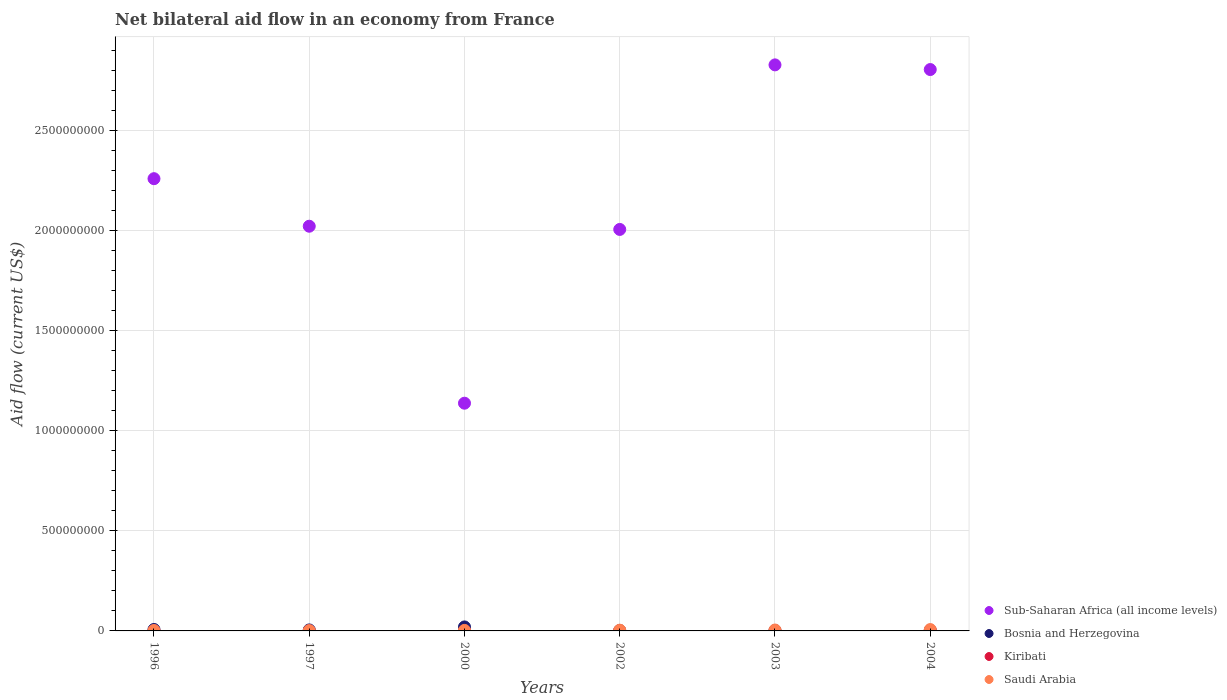How many different coloured dotlines are there?
Your response must be concise. 4. Is the number of dotlines equal to the number of legend labels?
Provide a short and direct response. Yes. What is the net bilateral aid flow in Sub-Saharan Africa (all income levels) in 2002?
Provide a succinct answer. 2.00e+09. Across all years, what is the maximum net bilateral aid flow in Saudi Arabia?
Offer a very short reply. 6.78e+06. Across all years, what is the minimum net bilateral aid flow in Kiribati?
Your answer should be compact. 10000. What is the total net bilateral aid flow in Saudi Arabia in the graph?
Your answer should be compact. 2.13e+07. What is the difference between the net bilateral aid flow in Saudi Arabia in 1996 and that in 2002?
Ensure brevity in your answer.  -1.63e+06. What is the difference between the net bilateral aid flow in Kiribati in 2003 and the net bilateral aid flow in Sub-Saharan Africa (all income levels) in 1997?
Give a very brief answer. -2.02e+09. What is the average net bilateral aid flow in Sub-Saharan Africa (all income levels) per year?
Provide a succinct answer. 2.17e+09. In the year 2004, what is the difference between the net bilateral aid flow in Bosnia and Herzegovina and net bilateral aid flow in Saudi Arabia?
Make the answer very short. -3.41e+06. In how many years, is the net bilateral aid flow in Bosnia and Herzegovina greater than 2000000000 US$?
Ensure brevity in your answer.  0. Is the difference between the net bilateral aid flow in Bosnia and Herzegovina in 2002 and 2003 greater than the difference between the net bilateral aid flow in Saudi Arabia in 2002 and 2003?
Give a very brief answer. Yes. What is the difference between the highest and the second highest net bilateral aid flow in Sub-Saharan Africa (all income levels)?
Ensure brevity in your answer.  2.33e+07. What is the difference between the highest and the lowest net bilateral aid flow in Bosnia and Herzegovina?
Provide a succinct answer. 1.78e+07. In how many years, is the net bilateral aid flow in Saudi Arabia greater than the average net bilateral aid flow in Saudi Arabia taken over all years?
Give a very brief answer. 3. Does the net bilateral aid flow in Bosnia and Herzegovina monotonically increase over the years?
Keep it short and to the point. No. How many dotlines are there?
Ensure brevity in your answer.  4. Are the values on the major ticks of Y-axis written in scientific E-notation?
Ensure brevity in your answer.  No. Does the graph contain any zero values?
Give a very brief answer. No. Does the graph contain grids?
Your answer should be very brief. Yes. Where does the legend appear in the graph?
Ensure brevity in your answer.  Bottom right. How many legend labels are there?
Your answer should be very brief. 4. How are the legend labels stacked?
Offer a terse response. Vertical. What is the title of the graph?
Give a very brief answer. Net bilateral aid flow in an economy from France. Does "Slovenia" appear as one of the legend labels in the graph?
Offer a terse response. No. What is the label or title of the X-axis?
Make the answer very short. Years. What is the Aid flow (current US$) in Sub-Saharan Africa (all income levels) in 1996?
Your answer should be very brief. 2.26e+09. What is the Aid flow (current US$) of Bosnia and Herzegovina in 1996?
Ensure brevity in your answer.  7.23e+06. What is the Aid flow (current US$) of Kiribati in 1996?
Give a very brief answer. 10000. What is the Aid flow (current US$) in Saudi Arabia in 1996?
Your answer should be very brief. 2.07e+06. What is the Aid flow (current US$) of Sub-Saharan Africa (all income levels) in 1997?
Keep it short and to the point. 2.02e+09. What is the Aid flow (current US$) of Bosnia and Herzegovina in 1997?
Provide a succinct answer. 4.96e+06. What is the Aid flow (current US$) of Kiribati in 1997?
Give a very brief answer. 10000. What is the Aid flow (current US$) in Saudi Arabia in 1997?
Your answer should be compact. 1.61e+06. What is the Aid flow (current US$) of Sub-Saharan Africa (all income levels) in 2000?
Provide a succinct answer. 1.14e+09. What is the Aid flow (current US$) of Bosnia and Herzegovina in 2000?
Provide a short and direct response. 1.99e+07. What is the Aid flow (current US$) in Saudi Arabia in 2000?
Offer a very short reply. 2.57e+06. What is the Aid flow (current US$) of Sub-Saharan Africa (all income levels) in 2002?
Give a very brief answer. 2.00e+09. What is the Aid flow (current US$) in Bosnia and Herzegovina in 2002?
Make the answer very short. 2.39e+06. What is the Aid flow (current US$) of Saudi Arabia in 2002?
Your answer should be very brief. 3.70e+06. What is the Aid flow (current US$) in Sub-Saharan Africa (all income levels) in 2003?
Ensure brevity in your answer.  2.83e+09. What is the Aid flow (current US$) in Bosnia and Herzegovina in 2003?
Your answer should be compact. 2.07e+06. What is the Aid flow (current US$) of Saudi Arabia in 2003?
Offer a very short reply. 4.55e+06. What is the Aid flow (current US$) in Sub-Saharan Africa (all income levels) in 2004?
Give a very brief answer. 2.80e+09. What is the Aid flow (current US$) of Bosnia and Herzegovina in 2004?
Make the answer very short. 3.37e+06. What is the Aid flow (current US$) of Saudi Arabia in 2004?
Offer a terse response. 6.78e+06. Across all years, what is the maximum Aid flow (current US$) in Sub-Saharan Africa (all income levels)?
Provide a succinct answer. 2.83e+09. Across all years, what is the maximum Aid flow (current US$) of Bosnia and Herzegovina?
Give a very brief answer. 1.99e+07. Across all years, what is the maximum Aid flow (current US$) of Saudi Arabia?
Keep it short and to the point. 6.78e+06. Across all years, what is the minimum Aid flow (current US$) in Sub-Saharan Africa (all income levels)?
Provide a short and direct response. 1.14e+09. Across all years, what is the minimum Aid flow (current US$) of Bosnia and Herzegovina?
Your answer should be compact. 2.07e+06. Across all years, what is the minimum Aid flow (current US$) in Kiribati?
Give a very brief answer. 10000. Across all years, what is the minimum Aid flow (current US$) of Saudi Arabia?
Make the answer very short. 1.61e+06. What is the total Aid flow (current US$) in Sub-Saharan Africa (all income levels) in the graph?
Provide a short and direct response. 1.30e+1. What is the total Aid flow (current US$) of Bosnia and Herzegovina in the graph?
Keep it short and to the point. 3.99e+07. What is the total Aid flow (current US$) in Saudi Arabia in the graph?
Offer a very short reply. 2.13e+07. What is the difference between the Aid flow (current US$) in Sub-Saharan Africa (all income levels) in 1996 and that in 1997?
Your answer should be compact. 2.37e+08. What is the difference between the Aid flow (current US$) of Bosnia and Herzegovina in 1996 and that in 1997?
Your response must be concise. 2.27e+06. What is the difference between the Aid flow (current US$) of Kiribati in 1996 and that in 1997?
Provide a succinct answer. 0. What is the difference between the Aid flow (current US$) of Sub-Saharan Africa (all income levels) in 1996 and that in 2000?
Your answer should be compact. 1.12e+09. What is the difference between the Aid flow (current US$) in Bosnia and Herzegovina in 1996 and that in 2000?
Your answer should be compact. -1.27e+07. What is the difference between the Aid flow (current US$) in Saudi Arabia in 1996 and that in 2000?
Provide a succinct answer. -5.00e+05. What is the difference between the Aid flow (current US$) in Sub-Saharan Africa (all income levels) in 1996 and that in 2002?
Your answer should be very brief. 2.53e+08. What is the difference between the Aid flow (current US$) of Bosnia and Herzegovina in 1996 and that in 2002?
Ensure brevity in your answer.  4.84e+06. What is the difference between the Aid flow (current US$) in Kiribati in 1996 and that in 2002?
Your answer should be compact. -5.00e+04. What is the difference between the Aid flow (current US$) in Saudi Arabia in 1996 and that in 2002?
Ensure brevity in your answer.  -1.63e+06. What is the difference between the Aid flow (current US$) in Sub-Saharan Africa (all income levels) in 1996 and that in 2003?
Ensure brevity in your answer.  -5.68e+08. What is the difference between the Aid flow (current US$) of Bosnia and Herzegovina in 1996 and that in 2003?
Ensure brevity in your answer.  5.16e+06. What is the difference between the Aid flow (current US$) of Kiribati in 1996 and that in 2003?
Ensure brevity in your answer.  -3.00e+04. What is the difference between the Aid flow (current US$) of Saudi Arabia in 1996 and that in 2003?
Your answer should be compact. -2.48e+06. What is the difference between the Aid flow (current US$) in Sub-Saharan Africa (all income levels) in 1996 and that in 2004?
Your response must be concise. -5.45e+08. What is the difference between the Aid flow (current US$) in Bosnia and Herzegovina in 1996 and that in 2004?
Provide a succinct answer. 3.86e+06. What is the difference between the Aid flow (current US$) in Kiribati in 1996 and that in 2004?
Your response must be concise. -3.00e+04. What is the difference between the Aid flow (current US$) of Saudi Arabia in 1996 and that in 2004?
Keep it short and to the point. -4.71e+06. What is the difference between the Aid flow (current US$) of Sub-Saharan Africa (all income levels) in 1997 and that in 2000?
Your answer should be very brief. 8.84e+08. What is the difference between the Aid flow (current US$) of Bosnia and Herzegovina in 1997 and that in 2000?
Make the answer very short. -1.50e+07. What is the difference between the Aid flow (current US$) in Kiribati in 1997 and that in 2000?
Offer a terse response. -10000. What is the difference between the Aid flow (current US$) in Saudi Arabia in 1997 and that in 2000?
Give a very brief answer. -9.60e+05. What is the difference between the Aid flow (current US$) in Sub-Saharan Africa (all income levels) in 1997 and that in 2002?
Offer a very short reply. 1.60e+07. What is the difference between the Aid flow (current US$) of Bosnia and Herzegovina in 1997 and that in 2002?
Your response must be concise. 2.57e+06. What is the difference between the Aid flow (current US$) of Saudi Arabia in 1997 and that in 2002?
Make the answer very short. -2.09e+06. What is the difference between the Aid flow (current US$) of Sub-Saharan Africa (all income levels) in 1997 and that in 2003?
Provide a short and direct response. -8.06e+08. What is the difference between the Aid flow (current US$) in Bosnia and Herzegovina in 1997 and that in 2003?
Provide a succinct answer. 2.89e+06. What is the difference between the Aid flow (current US$) in Saudi Arabia in 1997 and that in 2003?
Make the answer very short. -2.94e+06. What is the difference between the Aid flow (current US$) of Sub-Saharan Africa (all income levels) in 1997 and that in 2004?
Provide a short and direct response. -7.82e+08. What is the difference between the Aid flow (current US$) in Bosnia and Herzegovina in 1997 and that in 2004?
Your response must be concise. 1.59e+06. What is the difference between the Aid flow (current US$) of Kiribati in 1997 and that in 2004?
Make the answer very short. -3.00e+04. What is the difference between the Aid flow (current US$) in Saudi Arabia in 1997 and that in 2004?
Offer a very short reply. -5.17e+06. What is the difference between the Aid flow (current US$) of Sub-Saharan Africa (all income levels) in 2000 and that in 2002?
Provide a succinct answer. -8.68e+08. What is the difference between the Aid flow (current US$) in Bosnia and Herzegovina in 2000 and that in 2002?
Give a very brief answer. 1.75e+07. What is the difference between the Aid flow (current US$) of Saudi Arabia in 2000 and that in 2002?
Your response must be concise. -1.13e+06. What is the difference between the Aid flow (current US$) of Sub-Saharan Africa (all income levels) in 2000 and that in 2003?
Offer a terse response. -1.69e+09. What is the difference between the Aid flow (current US$) of Bosnia and Herzegovina in 2000 and that in 2003?
Provide a succinct answer. 1.78e+07. What is the difference between the Aid flow (current US$) in Saudi Arabia in 2000 and that in 2003?
Make the answer very short. -1.98e+06. What is the difference between the Aid flow (current US$) of Sub-Saharan Africa (all income levels) in 2000 and that in 2004?
Provide a short and direct response. -1.67e+09. What is the difference between the Aid flow (current US$) of Bosnia and Herzegovina in 2000 and that in 2004?
Your response must be concise. 1.65e+07. What is the difference between the Aid flow (current US$) of Saudi Arabia in 2000 and that in 2004?
Give a very brief answer. -4.21e+06. What is the difference between the Aid flow (current US$) in Sub-Saharan Africa (all income levels) in 2002 and that in 2003?
Your response must be concise. -8.22e+08. What is the difference between the Aid flow (current US$) in Bosnia and Herzegovina in 2002 and that in 2003?
Your answer should be compact. 3.20e+05. What is the difference between the Aid flow (current US$) in Kiribati in 2002 and that in 2003?
Make the answer very short. 2.00e+04. What is the difference between the Aid flow (current US$) in Saudi Arabia in 2002 and that in 2003?
Your response must be concise. -8.50e+05. What is the difference between the Aid flow (current US$) in Sub-Saharan Africa (all income levels) in 2002 and that in 2004?
Keep it short and to the point. -7.98e+08. What is the difference between the Aid flow (current US$) of Bosnia and Herzegovina in 2002 and that in 2004?
Offer a very short reply. -9.80e+05. What is the difference between the Aid flow (current US$) in Saudi Arabia in 2002 and that in 2004?
Provide a succinct answer. -3.08e+06. What is the difference between the Aid flow (current US$) in Sub-Saharan Africa (all income levels) in 2003 and that in 2004?
Provide a succinct answer. 2.33e+07. What is the difference between the Aid flow (current US$) in Bosnia and Herzegovina in 2003 and that in 2004?
Provide a short and direct response. -1.30e+06. What is the difference between the Aid flow (current US$) in Kiribati in 2003 and that in 2004?
Your response must be concise. 0. What is the difference between the Aid flow (current US$) of Saudi Arabia in 2003 and that in 2004?
Keep it short and to the point. -2.23e+06. What is the difference between the Aid flow (current US$) in Sub-Saharan Africa (all income levels) in 1996 and the Aid flow (current US$) in Bosnia and Herzegovina in 1997?
Offer a terse response. 2.25e+09. What is the difference between the Aid flow (current US$) in Sub-Saharan Africa (all income levels) in 1996 and the Aid flow (current US$) in Kiribati in 1997?
Provide a succinct answer. 2.26e+09. What is the difference between the Aid flow (current US$) in Sub-Saharan Africa (all income levels) in 1996 and the Aid flow (current US$) in Saudi Arabia in 1997?
Your answer should be compact. 2.26e+09. What is the difference between the Aid flow (current US$) of Bosnia and Herzegovina in 1996 and the Aid flow (current US$) of Kiribati in 1997?
Provide a short and direct response. 7.22e+06. What is the difference between the Aid flow (current US$) of Bosnia and Herzegovina in 1996 and the Aid flow (current US$) of Saudi Arabia in 1997?
Offer a very short reply. 5.62e+06. What is the difference between the Aid flow (current US$) in Kiribati in 1996 and the Aid flow (current US$) in Saudi Arabia in 1997?
Give a very brief answer. -1.60e+06. What is the difference between the Aid flow (current US$) in Sub-Saharan Africa (all income levels) in 1996 and the Aid flow (current US$) in Bosnia and Herzegovina in 2000?
Keep it short and to the point. 2.24e+09. What is the difference between the Aid flow (current US$) in Sub-Saharan Africa (all income levels) in 1996 and the Aid flow (current US$) in Kiribati in 2000?
Keep it short and to the point. 2.26e+09. What is the difference between the Aid flow (current US$) of Sub-Saharan Africa (all income levels) in 1996 and the Aid flow (current US$) of Saudi Arabia in 2000?
Provide a succinct answer. 2.26e+09. What is the difference between the Aid flow (current US$) of Bosnia and Herzegovina in 1996 and the Aid flow (current US$) of Kiribati in 2000?
Keep it short and to the point. 7.21e+06. What is the difference between the Aid flow (current US$) of Bosnia and Herzegovina in 1996 and the Aid flow (current US$) of Saudi Arabia in 2000?
Keep it short and to the point. 4.66e+06. What is the difference between the Aid flow (current US$) of Kiribati in 1996 and the Aid flow (current US$) of Saudi Arabia in 2000?
Offer a very short reply. -2.56e+06. What is the difference between the Aid flow (current US$) of Sub-Saharan Africa (all income levels) in 1996 and the Aid flow (current US$) of Bosnia and Herzegovina in 2002?
Provide a succinct answer. 2.26e+09. What is the difference between the Aid flow (current US$) in Sub-Saharan Africa (all income levels) in 1996 and the Aid flow (current US$) in Kiribati in 2002?
Your response must be concise. 2.26e+09. What is the difference between the Aid flow (current US$) in Sub-Saharan Africa (all income levels) in 1996 and the Aid flow (current US$) in Saudi Arabia in 2002?
Your response must be concise. 2.25e+09. What is the difference between the Aid flow (current US$) in Bosnia and Herzegovina in 1996 and the Aid flow (current US$) in Kiribati in 2002?
Keep it short and to the point. 7.17e+06. What is the difference between the Aid flow (current US$) in Bosnia and Herzegovina in 1996 and the Aid flow (current US$) in Saudi Arabia in 2002?
Make the answer very short. 3.53e+06. What is the difference between the Aid flow (current US$) of Kiribati in 1996 and the Aid flow (current US$) of Saudi Arabia in 2002?
Your response must be concise. -3.69e+06. What is the difference between the Aid flow (current US$) of Sub-Saharan Africa (all income levels) in 1996 and the Aid flow (current US$) of Bosnia and Herzegovina in 2003?
Provide a succinct answer. 2.26e+09. What is the difference between the Aid flow (current US$) in Sub-Saharan Africa (all income levels) in 1996 and the Aid flow (current US$) in Kiribati in 2003?
Ensure brevity in your answer.  2.26e+09. What is the difference between the Aid flow (current US$) in Sub-Saharan Africa (all income levels) in 1996 and the Aid flow (current US$) in Saudi Arabia in 2003?
Give a very brief answer. 2.25e+09. What is the difference between the Aid flow (current US$) in Bosnia and Herzegovina in 1996 and the Aid flow (current US$) in Kiribati in 2003?
Provide a succinct answer. 7.19e+06. What is the difference between the Aid flow (current US$) in Bosnia and Herzegovina in 1996 and the Aid flow (current US$) in Saudi Arabia in 2003?
Your response must be concise. 2.68e+06. What is the difference between the Aid flow (current US$) in Kiribati in 1996 and the Aid flow (current US$) in Saudi Arabia in 2003?
Give a very brief answer. -4.54e+06. What is the difference between the Aid flow (current US$) of Sub-Saharan Africa (all income levels) in 1996 and the Aid flow (current US$) of Bosnia and Herzegovina in 2004?
Your answer should be very brief. 2.25e+09. What is the difference between the Aid flow (current US$) in Sub-Saharan Africa (all income levels) in 1996 and the Aid flow (current US$) in Kiribati in 2004?
Your answer should be very brief. 2.26e+09. What is the difference between the Aid flow (current US$) in Sub-Saharan Africa (all income levels) in 1996 and the Aid flow (current US$) in Saudi Arabia in 2004?
Ensure brevity in your answer.  2.25e+09. What is the difference between the Aid flow (current US$) of Bosnia and Herzegovina in 1996 and the Aid flow (current US$) of Kiribati in 2004?
Offer a terse response. 7.19e+06. What is the difference between the Aid flow (current US$) of Kiribati in 1996 and the Aid flow (current US$) of Saudi Arabia in 2004?
Offer a very short reply. -6.77e+06. What is the difference between the Aid flow (current US$) of Sub-Saharan Africa (all income levels) in 1997 and the Aid flow (current US$) of Bosnia and Herzegovina in 2000?
Your response must be concise. 2.00e+09. What is the difference between the Aid flow (current US$) of Sub-Saharan Africa (all income levels) in 1997 and the Aid flow (current US$) of Kiribati in 2000?
Provide a succinct answer. 2.02e+09. What is the difference between the Aid flow (current US$) of Sub-Saharan Africa (all income levels) in 1997 and the Aid flow (current US$) of Saudi Arabia in 2000?
Your answer should be compact. 2.02e+09. What is the difference between the Aid flow (current US$) in Bosnia and Herzegovina in 1997 and the Aid flow (current US$) in Kiribati in 2000?
Your response must be concise. 4.94e+06. What is the difference between the Aid flow (current US$) of Bosnia and Herzegovina in 1997 and the Aid flow (current US$) of Saudi Arabia in 2000?
Provide a succinct answer. 2.39e+06. What is the difference between the Aid flow (current US$) of Kiribati in 1997 and the Aid flow (current US$) of Saudi Arabia in 2000?
Make the answer very short. -2.56e+06. What is the difference between the Aid flow (current US$) of Sub-Saharan Africa (all income levels) in 1997 and the Aid flow (current US$) of Bosnia and Herzegovina in 2002?
Give a very brief answer. 2.02e+09. What is the difference between the Aid flow (current US$) in Sub-Saharan Africa (all income levels) in 1997 and the Aid flow (current US$) in Kiribati in 2002?
Keep it short and to the point. 2.02e+09. What is the difference between the Aid flow (current US$) of Sub-Saharan Africa (all income levels) in 1997 and the Aid flow (current US$) of Saudi Arabia in 2002?
Your answer should be compact. 2.02e+09. What is the difference between the Aid flow (current US$) in Bosnia and Herzegovina in 1997 and the Aid flow (current US$) in Kiribati in 2002?
Keep it short and to the point. 4.90e+06. What is the difference between the Aid flow (current US$) in Bosnia and Herzegovina in 1997 and the Aid flow (current US$) in Saudi Arabia in 2002?
Your answer should be very brief. 1.26e+06. What is the difference between the Aid flow (current US$) in Kiribati in 1997 and the Aid flow (current US$) in Saudi Arabia in 2002?
Your response must be concise. -3.69e+06. What is the difference between the Aid flow (current US$) of Sub-Saharan Africa (all income levels) in 1997 and the Aid flow (current US$) of Bosnia and Herzegovina in 2003?
Keep it short and to the point. 2.02e+09. What is the difference between the Aid flow (current US$) of Sub-Saharan Africa (all income levels) in 1997 and the Aid flow (current US$) of Kiribati in 2003?
Make the answer very short. 2.02e+09. What is the difference between the Aid flow (current US$) in Sub-Saharan Africa (all income levels) in 1997 and the Aid flow (current US$) in Saudi Arabia in 2003?
Ensure brevity in your answer.  2.02e+09. What is the difference between the Aid flow (current US$) in Bosnia and Herzegovina in 1997 and the Aid flow (current US$) in Kiribati in 2003?
Your answer should be compact. 4.92e+06. What is the difference between the Aid flow (current US$) in Kiribati in 1997 and the Aid flow (current US$) in Saudi Arabia in 2003?
Ensure brevity in your answer.  -4.54e+06. What is the difference between the Aid flow (current US$) of Sub-Saharan Africa (all income levels) in 1997 and the Aid flow (current US$) of Bosnia and Herzegovina in 2004?
Make the answer very short. 2.02e+09. What is the difference between the Aid flow (current US$) in Sub-Saharan Africa (all income levels) in 1997 and the Aid flow (current US$) in Kiribati in 2004?
Make the answer very short. 2.02e+09. What is the difference between the Aid flow (current US$) in Sub-Saharan Africa (all income levels) in 1997 and the Aid flow (current US$) in Saudi Arabia in 2004?
Keep it short and to the point. 2.01e+09. What is the difference between the Aid flow (current US$) in Bosnia and Herzegovina in 1997 and the Aid flow (current US$) in Kiribati in 2004?
Your response must be concise. 4.92e+06. What is the difference between the Aid flow (current US$) of Bosnia and Herzegovina in 1997 and the Aid flow (current US$) of Saudi Arabia in 2004?
Your answer should be very brief. -1.82e+06. What is the difference between the Aid flow (current US$) in Kiribati in 1997 and the Aid flow (current US$) in Saudi Arabia in 2004?
Your answer should be compact. -6.77e+06. What is the difference between the Aid flow (current US$) in Sub-Saharan Africa (all income levels) in 2000 and the Aid flow (current US$) in Bosnia and Herzegovina in 2002?
Your response must be concise. 1.13e+09. What is the difference between the Aid flow (current US$) of Sub-Saharan Africa (all income levels) in 2000 and the Aid flow (current US$) of Kiribati in 2002?
Your response must be concise. 1.14e+09. What is the difference between the Aid flow (current US$) in Sub-Saharan Africa (all income levels) in 2000 and the Aid flow (current US$) in Saudi Arabia in 2002?
Offer a terse response. 1.13e+09. What is the difference between the Aid flow (current US$) in Bosnia and Herzegovina in 2000 and the Aid flow (current US$) in Kiribati in 2002?
Your answer should be compact. 1.98e+07. What is the difference between the Aid flow (current US$) in Bosnia and Herzegovina in 2000 and the Aid flow (current US$) in Saudi Arabia in 2002?
Provide a succinct answer. 1.62e+07. What is the difference between the Aid flow (current US$) in Kiribati in 2000 and the Aid flow (current US$) in Saudi Arabia in 2002?
Give a very brief answer. -3.68e+06. What is the difference between the Aid flow (current US$) in Sub-Saharan Africa (all income levels) in 2000 and the Aid flow (current US$) in Bosnia and Herzegovina in 2003?
Your answer should be compact. 1.13e+09. What is the difference between the Aid flow (current US$) of Sub-Saharan Africa (all income levels) in 2000 and the Aid flow (current US$) of Kiribati in 2003?
Offer a very short reply. 1.14e+09. What is the difference between the Aid flow (current US$) in Sub-Saharan Africa (all income levels) in 2000 and the Aid flow (current US$) in Saudi Arabia in 2003?
Make the answer very short. 1.13e+09. What is the difference between the Aid flow (current US$) in Bosnia and Herzegovina in 2000 and the Aid flow (current US$) in Kiribati in 2003?
Make the answer very short. 1.99e+07. What is the difference between the Aid flow (current US$) in Bosnia and Herzegovina in 2000 and the Aid flow (current US$) in Saudi Arabia in 2003?
Your response must be concise. 1.54e+07. What is the difference between the Aid flow (current US$) in Kiribati in 2000 and the Aid flow (current US$) in Saudi Arabia in 2003?
Your response must be concise. -4.53e+06. What is the difference between the Aid flow (current US$) in Sub-Saharan Africa (all income levels) in 2000 and the Aid flow (current US$) in Bosnia and Herzegovina in 2004?
Your answer should be very brief. 1.13e+09. What is the difference between the Aid flow (current US$) of Sub-Saharan Africa (all income levels) in 2000 and the Aid flow (current US$) of Kiribati in 2004?
Give a very brief answer. 1.14e+09. What is the difference between the Aid flow (current US$) in Sub-Saharan Africa (all income levels) in 2000 and the Aid flow (current US$) in Saudi Arabia in 2004?
Keep it short and to the point. 1.13e+09. What is the difference between the Aid flow (current US$) of Bosnia and Herzegovina in 2000 and the Aid flow (current US$) of Kiribati in 2004?
Your answer should be very brief. 1.99e+07. What is the difference between the Aid flow (current US$) in Bosnia and Herzegovina in 2000 and the Aid flow (current US$) in Saudi Arabia in 2004?
Your answer should be compact. 1.31e+07. What is the difference between the Aid flow (current US$) in Kiribati in 2000 and the Aid flow (current US$) in Saudi Arabia in 2004?
Provide a short and direct response. -6.76e+06. What is the difference between the Aid flow (current US$) of Sub-Saharan Africa (all income levels) in 2002 and the Aid flow (current US$) of Bosnia and Herzegovina in 2003?
Give a very brief answer. 2.00e+09. What is the difference between the Aid flow (current US$) of Sub-Saharan Africa (all income levels) in 2002 and the Aid flow (current US$) of Kiribati in 2003?
Your answer should be compact. 2.00e+09. What is the difference between the Aid flow (current US$) in Sub-Saharan Africa (all income levels) in 2002 and the Aid flow (current US$) in Saudi Arabia in 2003?
Provide a short and direct response. 2.00e+09. What is the difference between the Aid flow (current US$) of Bosnia and Herzegovina in 2002 and the Aid flow (current US$) of Kiribati in 2003?
Keep it short and to the point. 2.35e+06. What is the difference between the Aid flow (current US$) in Bosnia and Herzegovina in 2002 and the Aid flow (current US$) in Saudi Arabia in 2003?
Your answer should be compact. -2.16e+06. What is the difference between the Aid flow (current US$) of Kiribati in 2002 and the Aid flow (current US$) of Saudi Arabia in 2003?
Provide a short and direct response. -4.49e+06. What is the difference between the Aid flow (current US$) in Sub-Saharan Africa (all income levels) in 2002 and the Aid flow (current US$) in Bosnia and Herzegovina in 2004?
Your answer should be compact. 2.00e+09. What is the difference between the Aid flow (current US$) of Sub-Saharan Africa (all income levels) in 2002 and the Aid flow (current US$) of Kiribati in 2004?
Your answer should be very brief. 2.00e+09. What is the difference between the Aid flow (current US$) in Sub-Saharan Africa (all income levels) in 2002 and the Aid flow (current US$) in Saudi Arabia in 2004?
Offer a very short reply. 2.00e+09. What is the difference between the Aid flow (current US$) in Bosnia and Herzegovina in 2002 and the Aid flow (current US$) in Kiribati in 2004?
Your answer should be compact. 2.35e+06. What is the difference between the Aid flow (current US$) of Bosnia and Herzegovina in 2002 and the Aid flow (current US$) of Saudi Arabia in 2004?
Give a very brief answer. -4.39e+06. What is the difference between the Aid flow (current US$) in Kiribati in 2002 and the Aid flow (current US$) in Saudi Arabia in 2004?
Give a very brief answer. -6.72e+06. What is the difference between the Aid flow (current US$) in Sub-Saharan Africa (all income levels) in 2003 and the Aid flow (current US$) in Bosnia and Herzegovina in 2004?
Your answer should be compact. 2.82e+09. What is the difference between the Aid flow (current US$) of Sub-Saharan Africa (all income levels) in 2003 and the Aid flow (current US$) of Kiribati in 2004?
Make the answer very short. 2.83e+09. What is the difference between the Aid flow (current US$) in Sub-Saharan Africa (all income levels) in 2003 and the Aid flow (current US$) in Saudi Arabia in 2004?
Make the answer very short. 2.82e+09. What is the difference between the Aid flow (current US$) in Bosnia and Herzegovina in 2003 and the Aid flow (current US$) in Kiribati in 2004?
Offer a terse response. 2.03e+06. What is the difference between the Aid flow (current US$) of Bosnia and Herzegovina in 2003 and the Aid flow (current US$) of Saudi Arabia in 2004?
Offer a very short reply. -4.71e+06. What is the difference between the Aid flow (current US$) of Kiribati in 2003 and the Aid flow (current US$) of Saudi Arabia in 2004?
Ensure brevity in your answer.  -6.74e+06. What is the average Aid flow (current US$) in Sub-Saharan Africa (all income levels) per year?
Make the answer very short. 2.17e+09. What is the average Aid flow (current US$) of Bosnia and Herzegovina per year?
Offer a very short reply. 6.66e+06. What is the average Aid flow (current US$) of Kiribati per year?
Offer a very short reply. 3.00e+04. What is the average Aid flow (current US$) in Saudi Arabia per year?
Give a very brief answer. 3.55e+06. In the year 1996, what is the difference between the Aid flow (current US$) of Sub-Saharan Africa (all income levels) and Aid flow (current US$) of Bosnia and Herzegovina?
Ensure brevity in your answer.  2.25e+09. In the year 1996, what is the difference between the Aid flow (current US$) in Sub-Saharan Africa (all income levels) and Aid flow (current US$) in Kiribati?
Your answer should be very brief. 2.26e+09. In the year 1996, what is the difference between the Aid flow (current US$) in Sub-Saharan Africa (all income levels) and Aid flow (current US$) in Saudi Arabia?
Offer a terse response. 2.26e+09. In the year 1996, what is the difference between the Aid flow (current US$) of Bosnia and Herzegovina and Aid flow (current US$) of Kiribati?
Offer a very short reply. 7.22e+06. In the year 1996, what is the difference between the Aid flow (current US$) in Bosnia and Herzegovina and Aid flow (current US$) in Saudi Arabia?
Keep it short and to the point. 5.16e+06. In the year 1996, what is the difference between the Aid flow (current US$) in Kiribati and Aid flow (current US$) in Saudi Arabia?
Provide a short and direct response. -2.06e+06. In the year 1997, what is the difference between the Aid flow (current US$) in Sub-Saharan Africa (all income levels) and Aid flow (current US$) in Bosnia and Herzegovina?
Your response must be concise. 2.02e+09. In the year 1997, what is the difference between the Aid flow (current US$) of Sub-Saharan Africa (all income levels) and Aid flow (current US$) of Kiribati?
Keep it short and to the point. 2.02e+09. In the year 1997, what is the difference between the Aid flow (current US$) in Sub-Saharan Africa (all income levels) and Aid flow (current US$) in Saudi Arabia?
Give a very brief answer. 2.02e+09. In the year 1997, what is the difference between the Aid flow (current US$) of Bosnia and Herzegovina and Aid flow (current US$) of Kiribati?
Offer a terse response. 4.95e+06. In the year 1997, what is the difference between the Aid flow (current US$) of Bosnia and Herzegovina and Aid flow (current US$) of Saudi Arabia?
Offer a terse response. 3.35e+06. In the year 1997, what is the difference between the Aid flow (current US$) in Kiribati and Aid flow (current US$) in Saudi Arabia?
Your answer should be compact. -1.60e+06. In the year 2000, what is the difference between the Aid flow (current US$) in Sub-Saharan Africa (all income levels) and Aid flow (current US$) in Bosnia and Herzegovina?
Your answer should be compact. 1.12e+09. In the year 2000, what is the difference between the Aid flow (current US$) in Sub-Saharan Africa (all income levels) and Aid flow (current US$) in Kiribati?
Your response must be concise. 1.14e+09. In the year 2000, what is the difference between the Aid flow (current US$) of Sub-Saharan Africa (all income levels) and Aid flow (current US$) of Saudi Arabia?
Your response must be concise. 1.13e+09. In the year 2000, what is the difference between the Aid flow (current US$) in Bosnia and Herzegovina and Aid flow (current US$) in Kiribati?
Give a very brief answer. 1.99e+07. In the year 2000, what is the difference between the Aid flow (current US$) in Bosnia and Herzegovina and Aid flow (current US$) in Saudi Arabia?
Provide a succinct answer. 1.73e+07. In the year 2000, what is the difference between the Aid flow (current US$) in Kiribati and Aid flow (current US$) in Saudi Arabia?
Offer a very short reply. -2.55e+06. In the year 2002, what is the difference between the Aid flow (current US$) of Sub-Saharan Africa (all income levels) and Aid flow (current US$) of Bosnia and Herzegovina?
Keep it short and to the point. 2.00e+09. In the year 2002, what is the difference between the Aid flow (current US$) of Sub-Saharan Africa (all income levels) and Aid flow (current US$) of Kiribati?
Ensure brevity in your answer.  2.00e+09. In the year 2002, what is the difference between the Aid flow (current US$) of Sub-Saharan Africa (all income levels) and Aid flow (current US$) of Saudi Arabia?
Your answer should be compact. 2.00e+09. In the year 2002, what is the difference between the Aid flow (current US$) in Bosnia and Herzegovina and Aid flow (current US$) in Kiribati?
Offer a very short reply. 2.33e+06. In the year 2002, what is the difference between the Aid flow (current US$) in Bosnia and Herzegovina and Aid flow (current US$) in Saudi Arabia?
Give a very brief answer. -1.31e+06. In the year 2002, what is the difference between the Aid flow (current US$) of Kiribati and Aid flow (current US$) of Saudi Arabia?
Ensure brevity in your answer.  -3.64e+06. In the year 2003, what is the difference between the Aid flow (current US$) in Sub-Saharan Africa (all income levels) and Aid flow (current US$) in Bosnia and Herzegovina?
Offer a very short reply. 2.82e+09. In the year 2003, what is the difference between the Aid flow (current US$) of Sub-Saharan Africa (all income levels) and Aid flow (current US$) of Kiribati?
Your answer should be very brief. 2.83e+09. In the year 2003, what is the difference between the Aid flow (current US$) of Sub-Saharan Africa (all income levels) and Aid flow (current US$) of Saudi Arabia?
Offer a terse response. 2.82e+09. In the year 2003, what is the difference between the Aid flow (current US$) in Bosnia and Herzegovina and Aid flow (current US$) in Kiribati?
Offer a very short reply. 2.03e+06. In the year 2003, what is the difference between the Aid flow (current US$) in Bosnia and Herzegovina and Aid flow (current US$) in Saudi Arabia?
Your answer should be very brief. -2.48e+06. In the year 2003, what is the difference between the Aid flow (current US$) in Kiribati and Aid flow (current US$) in Saudi Arabia?
Your answer should be compact. -4.51e+06. In the year 2004, what is the difference between the Aid flow (current US$) in Sub-Saharan Africa (all income levels) and Aid flow (current US$) in Bosnia and Herzegovina?
Your answer should be very brief. 2.80e+09. In the year 2004, what is the difference between the Aid flow (current US$) in Sub-Saharan Africa (all income levels) and Aid flow (current US$) in Kiribati?
Make the answer very short. 2.80e+09. In the year 2004, what is the difference between the Aid flow (current US$) in Sub-Saharan Africa (all income levels) and Aid flow (current US$) in Saudi Arabia?
Your response must be concise. 2.80e+09. In the year 2004, what is the difference between the Aid flow (current US$) of Bosnia and Herzegovina and Aid flow (current US$) of Kiribati?
Your answer should be compact. 3.33e+06. In the year 2004, what is the difference between the Aid flow (current US$) in Bosnia and Herzegovina and Aid flow (current US$) in Saudi Arabia?
Provide a succinct answer. -3.41e+06. In the year 2004, what is the difference between the Aid flow (current US$) in Kiribati and Aid flow (current US$) in Saudi Arabia?
Your answer should be very brief. -6.74e+06. What is the ratio of the Aid flow (current US$) in Sub-Saharan Africa (all income levels) in 1996 to that in 1997?
Provide a short and direct response. 1.12. What is the ratio of the Aid flow (current US$) in Bosnia and Herzegovina in 1996 to that in 1997?
Your answer should be compact. 1.46. What is the ratio of the Aid flow (current US$) in Kiribati in 1996 to that in 1997?
Keep it short and to the point. 1. What is the ratio of the Aid flow (current US$) in Sub-Saharan Africa (all income levels) in 1996 to that in 2000?
Offer a terse response. 1.99. What is the ratio of the Aid flow (current US$) of Bosnia and Herzegovina in 1996 to that in 2000?
Give a very brief answer. 0.36. What is the ratio of the Aid flow (current US$) of Kiribati in 1996 to that in 2000?
Offer a very short reply. 0.5. What is the ratio of the Aid flow (current US$) in Saudi Arabia in 1996 to that in 2000?
Keep it short and to the point. 0.81. What is the ratio of the Aid flow (current US$) of Sub-Saharan Africa (all income levels) in 1996 to that in 2002?
Your answer should be very brief. 1.13. What is the ratio of the Aid flow (current US$) of Bosnia and Herzegovina in 1996 to that in 2002?
Offer a terse response. 3.03. What is the ratio of the Aid flow (current US$) in Kiribati in 1996 to that in 2002?
Your answer should be compact. 0.17. What is the ratio of the Aid flow (current US$) of Saudi Arabia in 1996 to that in 2002?
Give a very brief answer. 0.56. What is the ratio of the Aid flow (current US$) of Sub-Saharan Africa (all income levels) in 1996 to that in 2003?
Provide a short and direct response. 0.8. What is the ratio of the Aid flow (current US$) of Bosnia and Herzegovina in 1996 to that in 2003?
Ensure brevity in your answer.  3.49. What is the ratio of the Aid flow (current US$) in Saudi Arabia in 1996 to that in 2003?
Give a very brief answer. 0.45. What is the ratio of the Aid flow (current US$) in Sub-Saharan Africa (all income levels) in 1996 to that in 2004?
Provide a succinct answer. 0.81. What is the ratio of the Aid flow (current US$) in Bosnia and Herzegovina in 1996 to that in 2004?
Your answer should be very brief. 2.15. What is the ratio of the Aid flow (current US$) of Kiribati in 1996 to that in 2004?
Keep it short and to the point. 0.25. What is the ratio of the Aid flow (current US$) in Saudi Arabia in 1996 to that in 2004?
Keep it short and to the point. 0.31. What is the ratio of the Aid flow (current US$) in Sub-Saharan Africa (all income levels) in 1997 to that in 2000?
Give a very brief answer. 1.78. What is the ratio of the Aid flow (current US$) in Bosnia and Herzegovina in 1997 to that in 2000?
Offer a very short reply. 0.25. What is the ratio of the Aid flow (current US$) of Saudi Arabia in 1997 to that in 2000?
Offer a terse response. 0.63. What is the ratio of the Aid flow (current US$) in Bosnia and Herzegovina in 1997 to that in 2002?
Provide a succinct answer. 2.08. What is the ratio of the Aid flow (current US$) in Kiribati in 1997 to that in 2002?
Keep it short and to the point. 0.17. What is the ratio of the Aid flow (current US$) in Saudi Arabia in 1997 to that in 2002?
Offer a very short reply. 0.44. What is the ratio of the Aid flow (current US$) in Sub-Saharan Africa (all income levels) in 1997 to that in 2003?
Keep it short and to the point. 0.71. What is the ratio of the Aid flow (current US$) of Bosnia and Herzegovina in 1997 to that in 2003?
Keep it short and to the point. 2.4. What is the ratio of the Aid flow (current US$) in Kiribati in 1997 to that in 2003?
Offer a terse response. 0.25. What is the ratio of the Aid flow (current US$) in Saudi Arabia in 1997 to that in 2003?
Keep it short and to the point. 0.35. What is the ratio of the Aid flow (current US$) of Sub-Saharan Africa (all income levels) in 1997 to that in 2004?
Keep it short and to the point. 0.72. What is the ratio of the Aid flow (current US$) in Bosnia and Herzegovina in 1997 to that in 2004?
Make the answer very short. 1.47. What is the ratio of the Aid flow (current US$) in Kiribati in 1997 to that in 2004?
Ensure brevity in your answer.  0.25. What is the ratio of the Aid flow (current US$) in Saudi Arabia in 1997 to that in 2004?
Your answer should be compact. 0.24. What is the ratio of the Aid flow (current US$) in Sub-Saharan Africa (all income levels) in 2000 to that in 2002?
Give a very brief answer. 0.57. What is the ratio of the Aid flow (current US$) of Bosnia and Herzegovina in 2000 to that in 2002?
Provide a short and direct response. 8.33. What is the ratio of the Aid flow (current US$) in Saudi Arabia in 2000 to that in 2002?
Offer a terse response. 0.69. What is the ratio of the Aid flow (current US$) in Sub-Saharan Africa (all income levels) in 2000 to that in 2003?
Keep it short and to the point. 0.4. What is the ratio of the Aid flow (current US$) in Bosnia and Herzegovina in 2000 to that in 2003?
Make the answer very short. 9.62. What is the ratio of the Aid flow (current US$) of Saudi Arabia in 2000 to that in 2003?
Keep it short and to the point. 0.56. What is the ratio of the Aid flow (current US$) of Sub-Saharan Africa (all income levels) in 2000 to that in 2004?
Offer a terse response. 0.41. What is the ratio of the Aid flow (current US$) of Bosnia and Herzegovina in 2000 to that in 2004?
Offer a very short reply. 5.91. What is the ratio of the Aid flow (current US$) in Saudi Arabia in 2000 to that in 2004?
Your response must be concise. 0.38. What is the ratio of the Aid flow (current US$) of Sub-Saharan Africa (all income levels) in 2002 to that in 2003?
Offer a very short reply. 0.71. What is the ratio of the Aid flow (current US$) in Bosnia and Herzegovina in 2002 to that in 2003?
Make the answer very short. 1.15. What is the ratio of the Aid flow (current US$) in Kiribati in 2002 to that in 2003?
Keep it short and to the point. 1.5. What is the ratio of the Aid flow (current US$) in Saudi Arabia in 2002 to that in 2003?
Offer a very short reply. 0.81. What is the ratio of the Aid flow (current US$) in Sub-Saharan Africa (all income levels) in 2002 to that in 2004?
Offer a terse response. 0.72. What is the ratio of the Aid flow (current US$) in Bosnia and Herzegovina in 2002 to that in 2004?
Your response must be concise. 0.71. What is the ratio of the Aid flow (current US$) in Kiribati in 2002 to that in 2004?
Your response must be concise. 1.5. What is the ratio of the Aid flow (current US$) in Saudi Arabia in 2002 to that in 2004?
Offer a very short reply. 0.55. What is the ratio of the Aid flow (current US$) in Sub-Saharan Africa (all income levels) in 2003 to that in 2004?
Ensure brevity in your answer.  1.01. What is the ratio of the Aid flow (current US$) of Bosnia and Herzegovina in 2003 to that in 2004?
Give a very brief answer. 0.61. What is the ratio of the Aid flow (current US$) of Kiribati in 2003 to that in 2004?
Offer a very short reply. 1. What is the ratio of the Aid flow (current US$) of Saudi Arabia in 2003 to that in 2004?
Provide a succinct answer. 0.67. What is the difference between the highest and the second highest Aid flow (current US$) in Sub-Saharan Africa (all income levels)?
Provide a succinct answer. 2.33e+07. What is the difference between the highest and the second highest Aid flow (current US$) in Bosnia and Herzegovina?
Keep it short and to the point. 1.27e+07. What is the difference between the highest and the second highest Aid flow (current US$) of Saudi Arabia?
Your response must be concise. 2.23e+06. What is the difference between the highest and the lowest Aid flow (current US$) in Sub-Saharan Africa (all income levels)?
Offer a very short reply. 1.69e+09. What is the difference between the highest and the lowest Aid flow (current US$) in Bosnia and Herzegovina?
Your response must be concise. 1.78e+07. What is the difference between the highest and the lowest Aid flow (current US$) of Kiribati?
Your answer should be compact. 5.00e+04. What is the difference between the highest and the lowest Aid flow (current US$) of Saudi Arabia?
Give a very brief answer. 5.17e+06. 